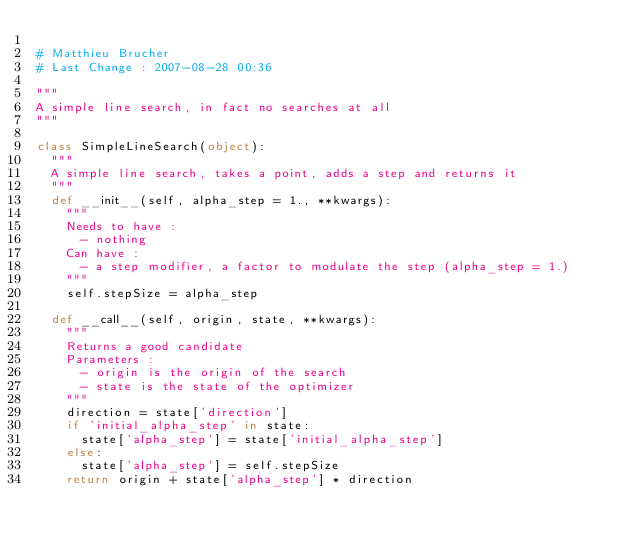Convert code to text. <code><loc_0><loc_0><loc_500><loc_500><_Python_>
# Matthieu Brucher
# Last Change : 2007-08-28 00:36

"""
A simple line search, in fact no searches at all
"""

class SimpleLineSearch(object):
  """
  A simple line search, takes a point, adds a step and returns it
  """
  def __init__(self, alpha_step = 1., **kwargs):
    """
    Needs to have :
      - nothing
    Can have :
      - a step modifier, a factor to modulate the step (alpha_step = 1.)
    """
    self.stepSize = alpha_step

  def __call__(self, origin, state, **kwargs):
    """
    Returns a good candidate
    Parameters :
      - origin is the origin of the search
      - state is the state of the optimizer
    """
    direction = state['direction']
    if 'initial_alpha_step' in state:
      state['alpha_step'] = state['initial_alpha_step']
    else:
      state['alpha_step'] = self.stepSize
    return origin + state['alpha_step'] * direction

</code> 